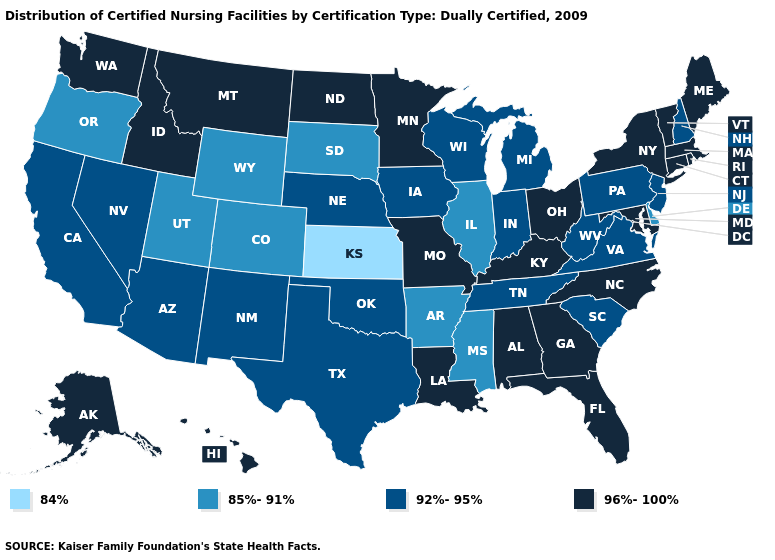Does Nevada have a higher value than North Carolina?
Write a very short answer. No. Name the states that have a value in the range 92%-95%?
Be succinct. Arizona, California, Indiana, Iowa, Michigan, Nebraska, Nevada, New Hampshire, New Jersey, New Mexico, Oklahoma, Pennsylvania, South Carolina, Tennessee, Texas, Virginia, West Virginia, Wisconsin. Name the states that have a value in the range 96%-100%?
Concise answer only. Alabama, Alaska, Connecticut, Florida, Georgia, Hawaii, Idaho, Kentucky, Louisiana, Maine, Maryland, Massachusetts, Minnesota, Missouri, Montana, New York, North Carolina, North Dakota, Ohio, Rhode Island, Vermont, Washington. Among the states that border Wyoming , which have the lowest value?
Keep it brief. Colorado, South Dakota, Utah. Among the states that border South Dakota , which have the lowest value?
Be succinct. Wyoming. Does Utah have the highest value in the USA?
Answer briefly. No. Is the legend a continuous bar?
Give a very brief answer. No. Among the states that border Louisiana , which have the highest value?
Quick response, please. Texas. What is the value of Pennsylvania?
Write a very short answer. 92%-95%. What is the value of Nebraska?
Concise answer only. 92%-95%. Among the states that border Arkansas , does Mississippi have the lowest value?
Quick response, please. Yes. What is the lowest value in the Northeast?
Write a very short answer. 92%-95%. Among the states that border Pennsylvania , which have the lowest value?
Write a very short answer. Delaware. Does Indiana have the highest value in the MidWest?
Quick response, please. No. Does Illinois have the same value as New York?
Give a very brief answer. No. 